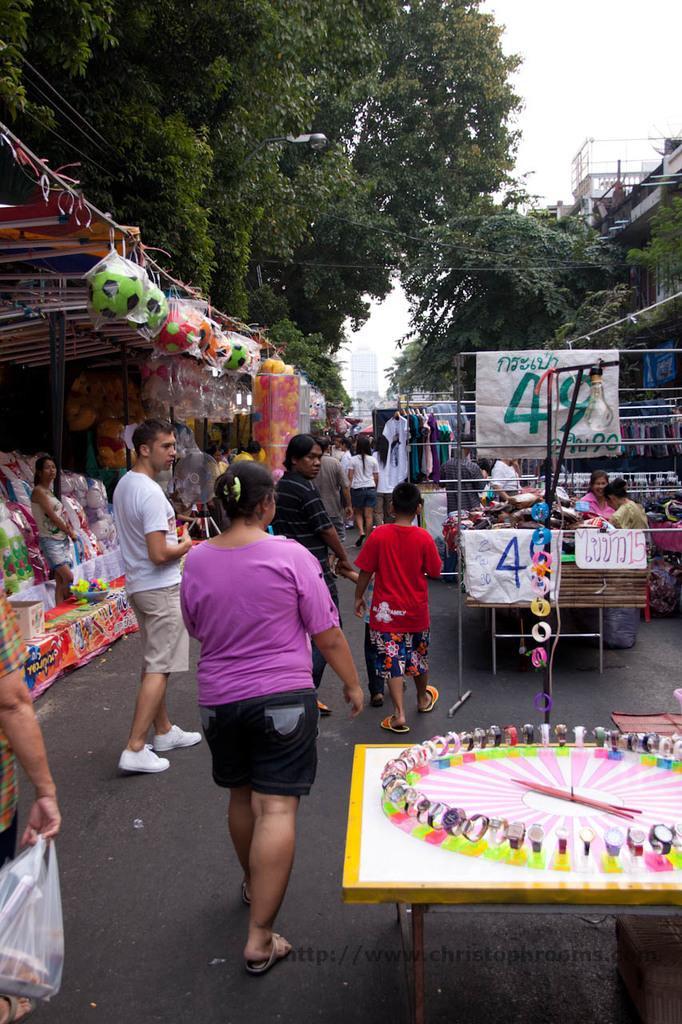Can you describe this image briefly? In this picture we can see a group of people walking on the road, stalls, balls, trees and some toys and in the background we can see the sky. 